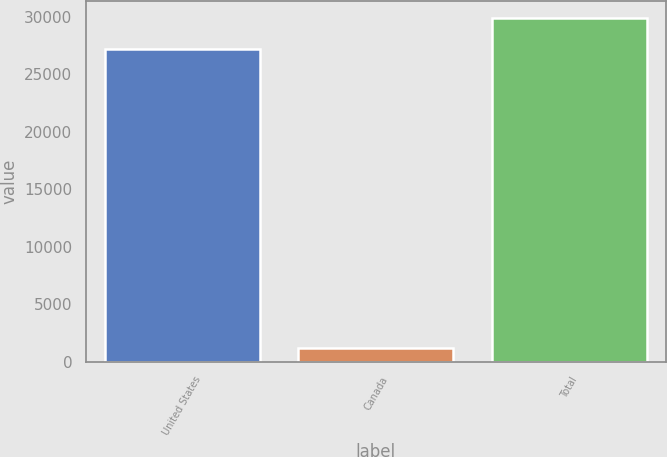<chart> <loc_0><loc_0><loc_500><loc_500><bar_chart><fcel>United States<fcel>Canada<fcel>Total<nl><fcel>27171<fcel>1207<fcel>29888.1<nl></chart> 